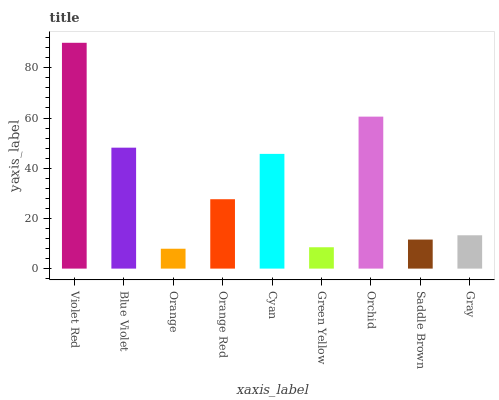Is Orange the minimum?
Answer yes or no. Yes. Is Violet Red the maximum?
Answer yes or no. Yes. Is Blue Violet the minimum?
Answer yes or no. No. Is Blue Violet the maximum?
Answer yes or no. No. Is Violet Red greater than Blue Violet?
Answer yes or no. Yes. Is Blue Violet less than Violet Red?
Answer yes or no. Yes. Is Blue Violet greater than Violet Red?
Answer yes or no. No. Is Violet Red less than Blue Violet?
Answer yes or no. No. Is Orange Red the high median?
Answer yes or no. Yes. Is Orange Red the low median?
Answer yes or no. Yes. Is Blue Violet the high median?
Answer yes or no. No. Is Green Yellow the low median?
Answer yes or no. No. 